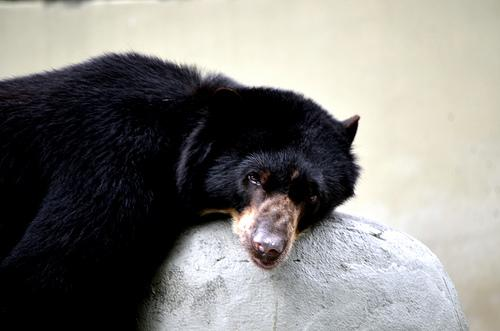Question: what is in the picture?
Choices:
A. A bear.
B. A cat.
C. A dog.
D. A moose.
Answer with the letter. Answer: A Question: how many bears are there?
Choices:
A. Two.
B. Three.
C. One.
D. Four.
Answer with the letter. Answer: C 